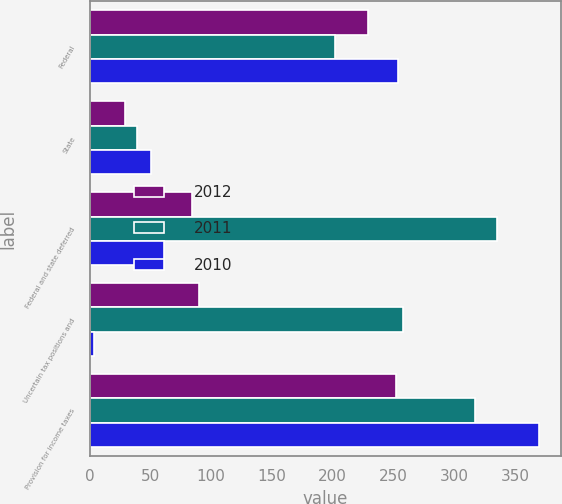Convert chart. <chart><loc_0><loc_0><loc_500><loc_500><stacked_bar_chart><ecel><fcel>Federal<fcel>State<fcel>Federal and state deferred<fcel>Uncertain tax positions and<fcel>Provision for income taxes<nl><fcel>2012<fcel>228.7<fcel>29.2<fcel>83.9<fcel>90<fcel>251.8<nl><fcel>2011<fcel>201.7<fcel>38.6<fcel>334.8<fcel>257.7<fcel>317.4<nl><fcel>2010<fcel>253.9<fcel>50.2<fcel>61.4<fcel>4<fcel>369.5<nl></chart> 